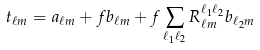<formula> <loc_0><loc_0><loc_500><loc_500>t _ { \ell m } = a _ { \ell m } + f b _ { \ell m } + f \sum _ { \ell _ { 1 } \ell _ { 2 } } R _ { \ell m } ^ { \ell _ { 1 } \ell _ { 2 } } b _ { \ell _ { 2 } m }</formula> 